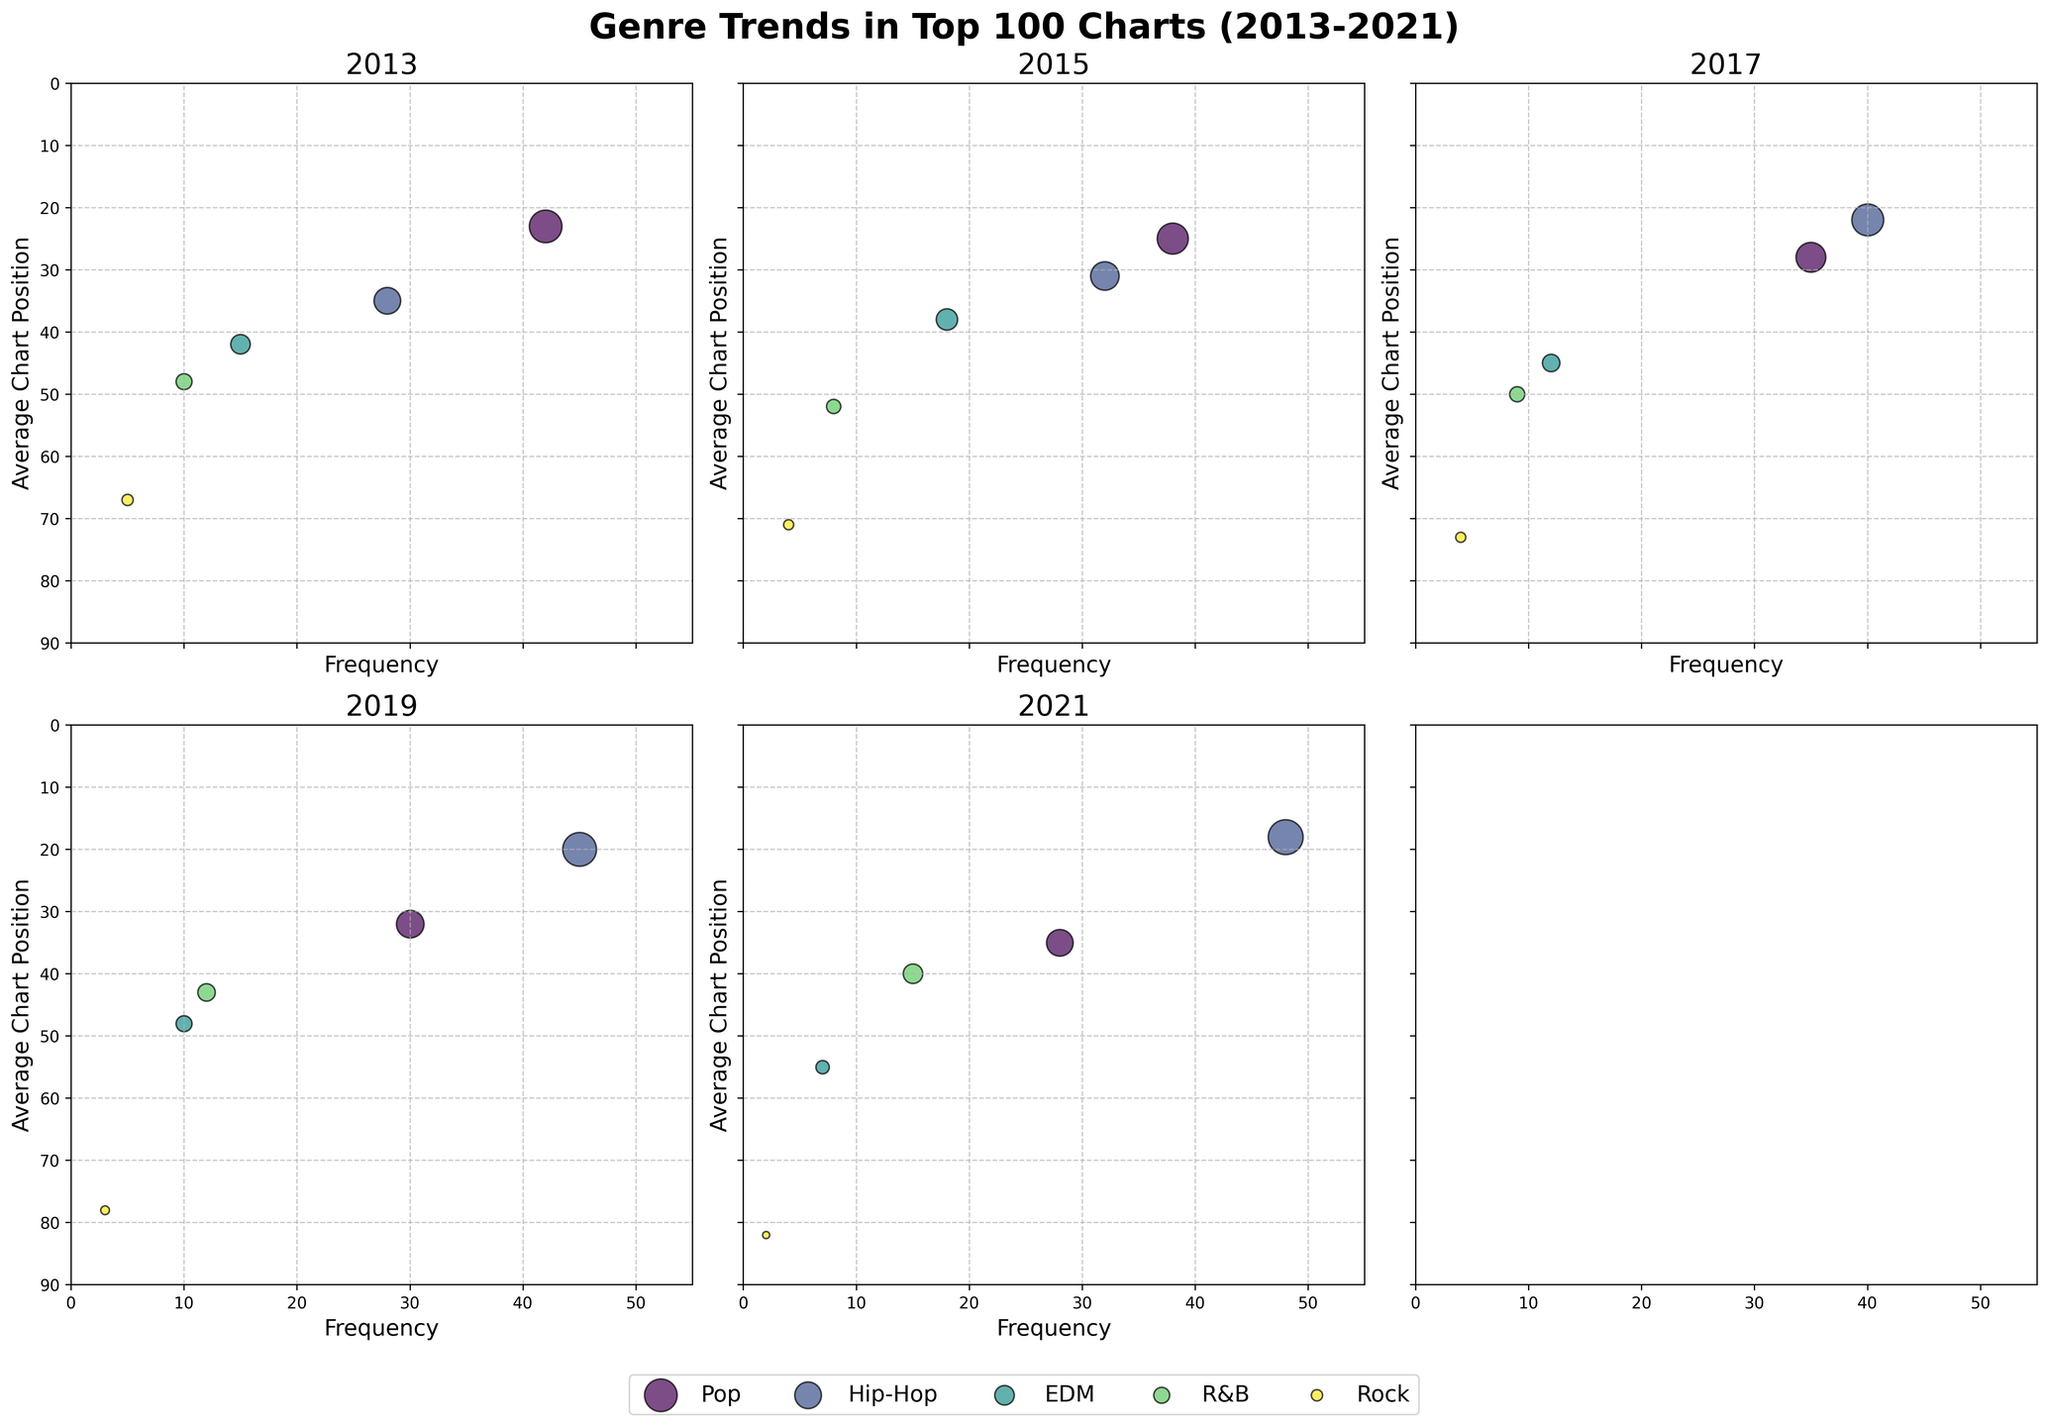what is the title of the figure? The title can be found at the top center of the figure, usually in a larger font than other text. Look for bold or highlighted text that summarizes the content of the plots.
Answer: Genre Trends in Top 100 Charts (2013-2021) In what year did Hip-Hop have the highest frequency? To find this, locate the point representing Hip-Hop on each subplot. Compare the 'Frequency' values; find the subplot with the highest value for Hip-Hop.
Answer: 2021 Which genre has the smallest average chart position in 2019? The smaller average chart position is a lower number in the y-axis (noting that the y-axis is inverted). Look for the lowest dot within the 2019 subplot under the Hip-Hop genre.
Answer: Hip-Hop How does the frequency of Pop in 2013 compare to its frequency in 2021? Check the 'Frequency' values for Pop in the 2013 and 2021 subplots. Compare these values directly.
Answer: Higher in 2013 What are the x-axis and y-axis labels in each subplot? Each subplot has labels on the x and y axes. Look for the terms that appear consistently across all subplots to define Frequency and Average Chart Position.
Answer: Frequency (x-axis), Average Chart Position (y-axis) How did the trend of Rock genre change from 2013 to 2021? Examine the Rock data points across all subplots from 2013 to 2021. Look for changes in 'Frequency' and 'Average Chart Position' over these years. Note the trend of Rock's decline in 'Frequency' over the years.
Answer: Frequency decreased Which genre had the highest average chart position in 2017? Look for the highest average chart position (lowest dot, since the axis is inverted) within the 2017 subplot. Find the corresponding genre beside this point.
Answer: Hip-Hop What is the overall trend observed in the Hip-Hop genre from 2013 to 2021 in terms of frequency? Check the Hip-Hop points across all subplots from 2013 to 2021. Track how the 'Frequency' has changed over the years, noting any patterns or increases.
Answer: Increasing trend In 2019, which genre had a better average chart position, R&B or EDM? Find the points for R&B and EDM within the 2019 subplot. Compare their y-axis values, noting the lower value represents a better chart position.
Answer: R&B 